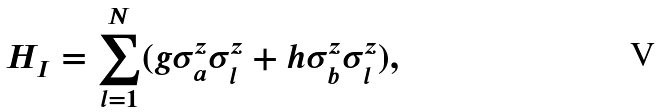<formula> <loc_0><loc_0><loc_500><loc_500>H _ { I } = \sum _ { l = 1 } ^ { N } ( g \sigma _ { a } ^ { z } \sigma _ { l } ^ { z } + h \sigma _ { b } ^ { z } \sigma _ { l } ^ { z } ) ,</formula> 